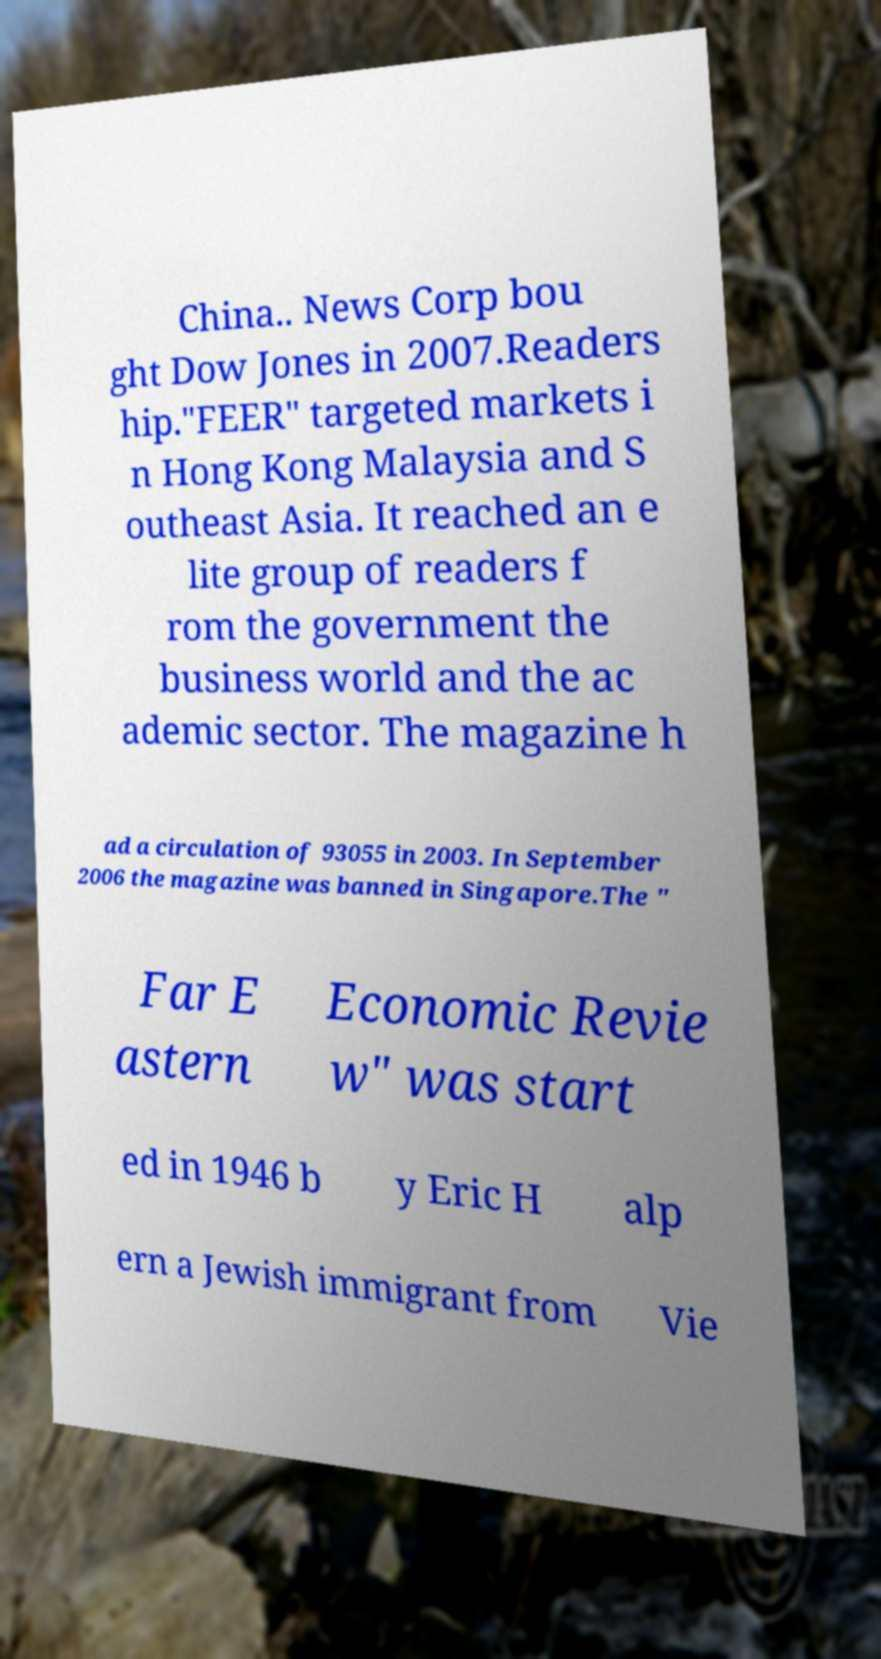What messages or text are displayed in this image? I need them in a readable, typed format. China.. News Corp bou ght Dow Jones in 2007.Readers hip."FEER" targeted markets i n Hong Kong Malaysia and S outheast Asia. It reached an e lite group of readers f rom the government the business world and the ac ademic sector. The magazine h ad a circulation of 93055 in 2003. In September 2006 the magazine was banned in Singapore.The " Far E astern Economic Revie w" was start ed in 1946 b y Eric H alp ern a Jewish immigrant from Vie 